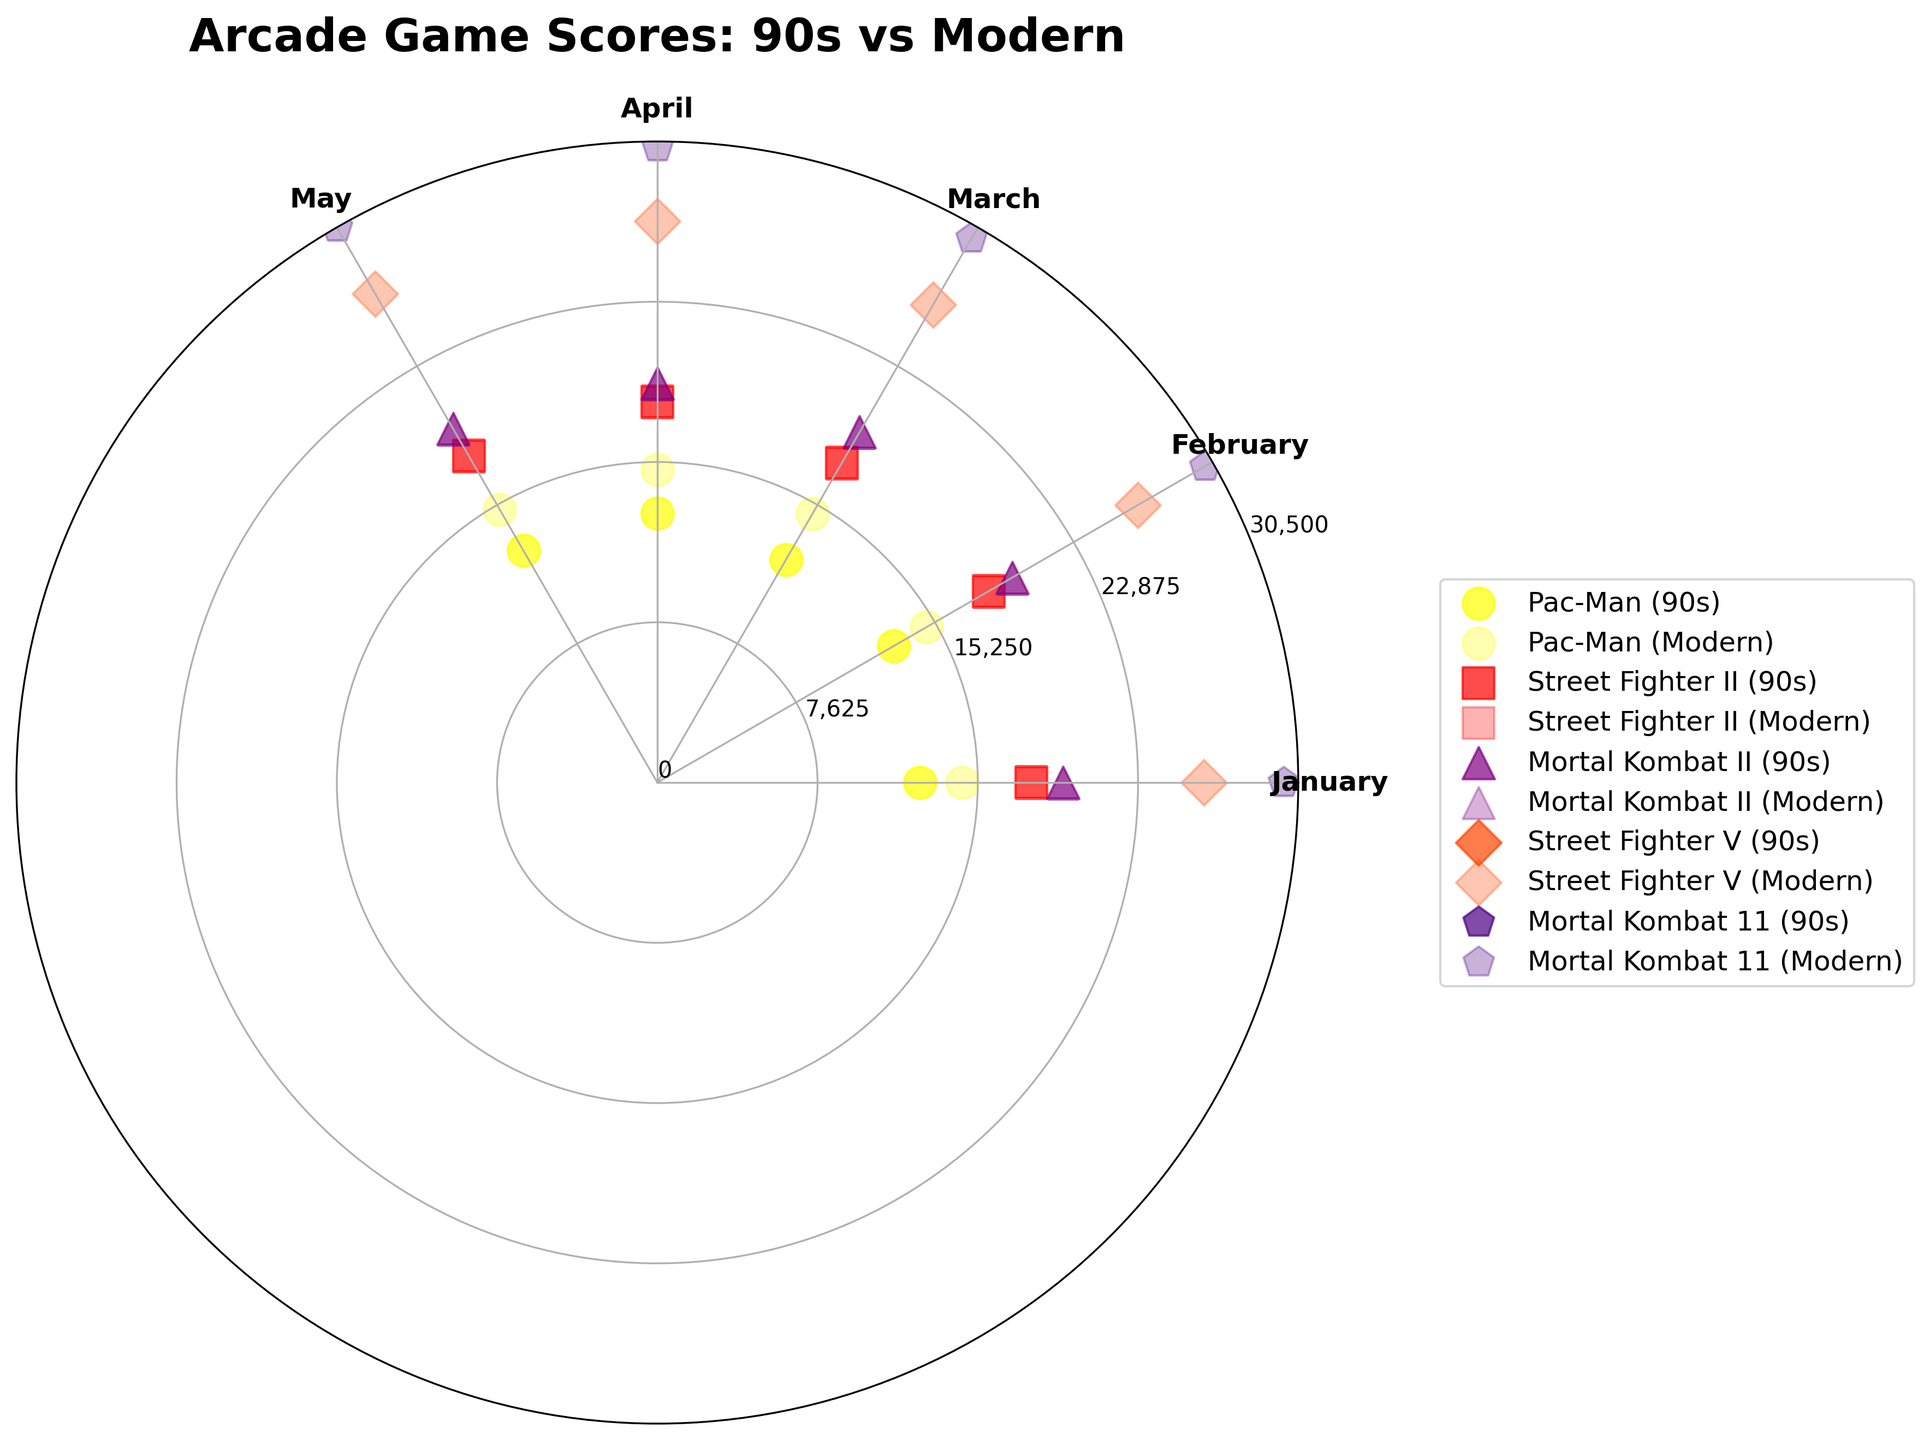How many different video games have data points on the chart? To determine this, we count the unique game names represented on the chart. There are entries for Pac-Man, Street Fighter II, Mortal Kombat II, Street Fighter V, and Mortal Kombat 11.
Answer: 5 Which game shows the highest normalized score in the 90s according to the plot? By inspecting the plotted points for the years before 2000, we see that Mortal Kombat II has the highest normalized score points in the 90s.
Answer: Mortal Kombat II In which month did Street Fighter V achieve its highest normalized score? Inspecting the plotted points for Street Fighter V, the highest normalized score occurs in May.
Answer: May Compare the performance between Pac-Man in 1992 and 2022. We examine the angles and normalized scores of Pac-Man for both years. The normalized scores for 2022 are consistently higher at each corresponding month compared to 1992.
Answer: Modern scores are higher What is the color representation of Pac-Man on the chart? By observing the plotted points, Pac-Man data points are represented in yellow.
Answer: Yellow Which game shows a significant difference in scores between the 90s and modern times? By comparing the visual data between the 90s and modern times, Street Fighter V has much higher normalized scores compared to Street Fighter II, indicating a significant difference.
Answer: Street Fighter Which game has the most consistent performance over the months in 2022? By looking at the modern game data points' normalized scores, Pac-Man's scores are relatively consistent compared to other games.
Answer: Pac-Man What is the title of the chart? The title displayed at the top of the chart is "Arcade Game Scores: 90s vs Modern".
Answer: Arcade Game Scores: 90s vs Modern What marker shape represents Mortal Kombat II? Examining the markers, Mortal Kombat II is represented with a triangle marker.
Answer: Triangle What is the maximum score that the radial axis label represents? The radial axis labels indicate the maximum normalized score represents a score of 30,500.
Answer: 30,500 